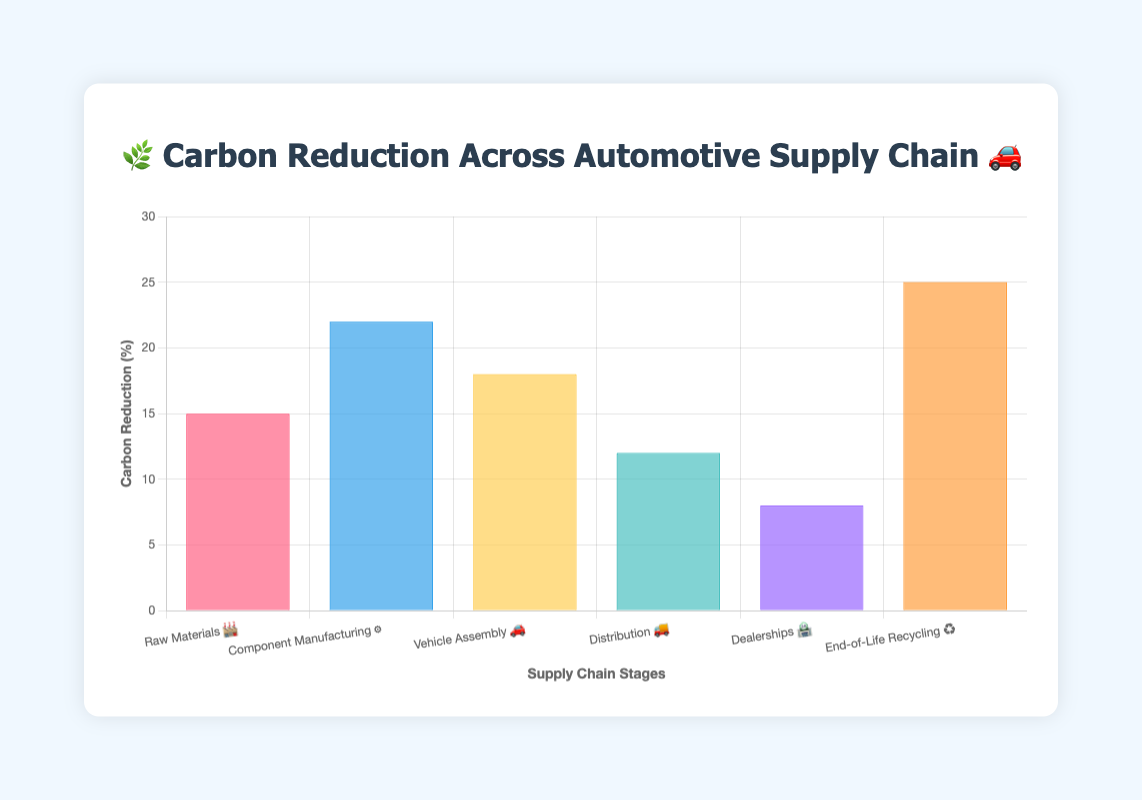What is the title of the chart? The title is prominently displayed at the top of the chart. It reads "🌿 Carbon Reduction Across Automotive Supply Chain 🚗".
Answer: 🌿 Carbon Reduction Across Automotive Supply Chain 🚗 Which supply chain stage achieved the highest percentage of carbon reduction? By looking at the height of the bars representing each stage, the "End-of-Life Recycling" stage has the tallest bar, indicating the highest carbon reduction percentage.
Answer: End-of-Life Recycling What is the carbon reduction percentage for Component Manufacturing ⚙️? Referring to the height of the bar labeled "Component Manufacturing ⚙️," we see it reaches 22% on the y-axis.
Answer: 22% How many percentage points higher is the carbon reduction in Vehicle Assembly 🚗 compared to Dealerships 🏪? Vehicle Assembly 🚗 has 18% carbon reduction and Dealerships 🏪 have 8%. Subtracting these gives 18% - 8% = 10%.
Answer: 10 percentage points What is the total carbon reduction percentage across all stages? Adding the carbon reductions: 15% (Raw Materials 🏭) + 22% (Component Manufacturing ⚙️) + 18% (Vehicle Assembly 🚗) + 12% (Distribution 🚚) + 8% (Dealerships 🏪) + 25% (End-of-Life Recycling ♻️) gives 100%.
Answer: 100% Which stages have carbon reductions greater than 15%? Observing the bars that extend above the 15% mark, "Component Manufacturing ⚙️", "Vehicle Assembly 🚗", and "End-of-Life Recycling ♻️" all have reductions greater than 15%.
Answer: Component Manufacturing, Vehicle Assembly, End-of-Life Recycling What is the difference in carbon reduction between the stages with the maximum and minimum reductions? The maximum reduction is 25% in End-of-Life Recycling ♻️ and the minimum is 8% in Dealerships 🏪. The difference is 25% - 8% = 17%.
Answer: 17 percentage points If the average carbon reduction of all stages is calculated, what would it be? To find the average, sum all reductions (15% + 22% + 18% + 12% + 8% + 25% = 100%) and divide by the number of stages (6), which gives 100% / 6 ≈ 16.67%.
Answer: ~16.67% Which stages fall below the average carbon reduction percentage? The calculated average is approximately 16.67%. The stages below this average are "Raw Materials 🏭" (15%), "Distribution 🚚" (12%), and "Dealerships 🏪" (8%).
Answer: Raw Materials, Distribution, Dealerships 